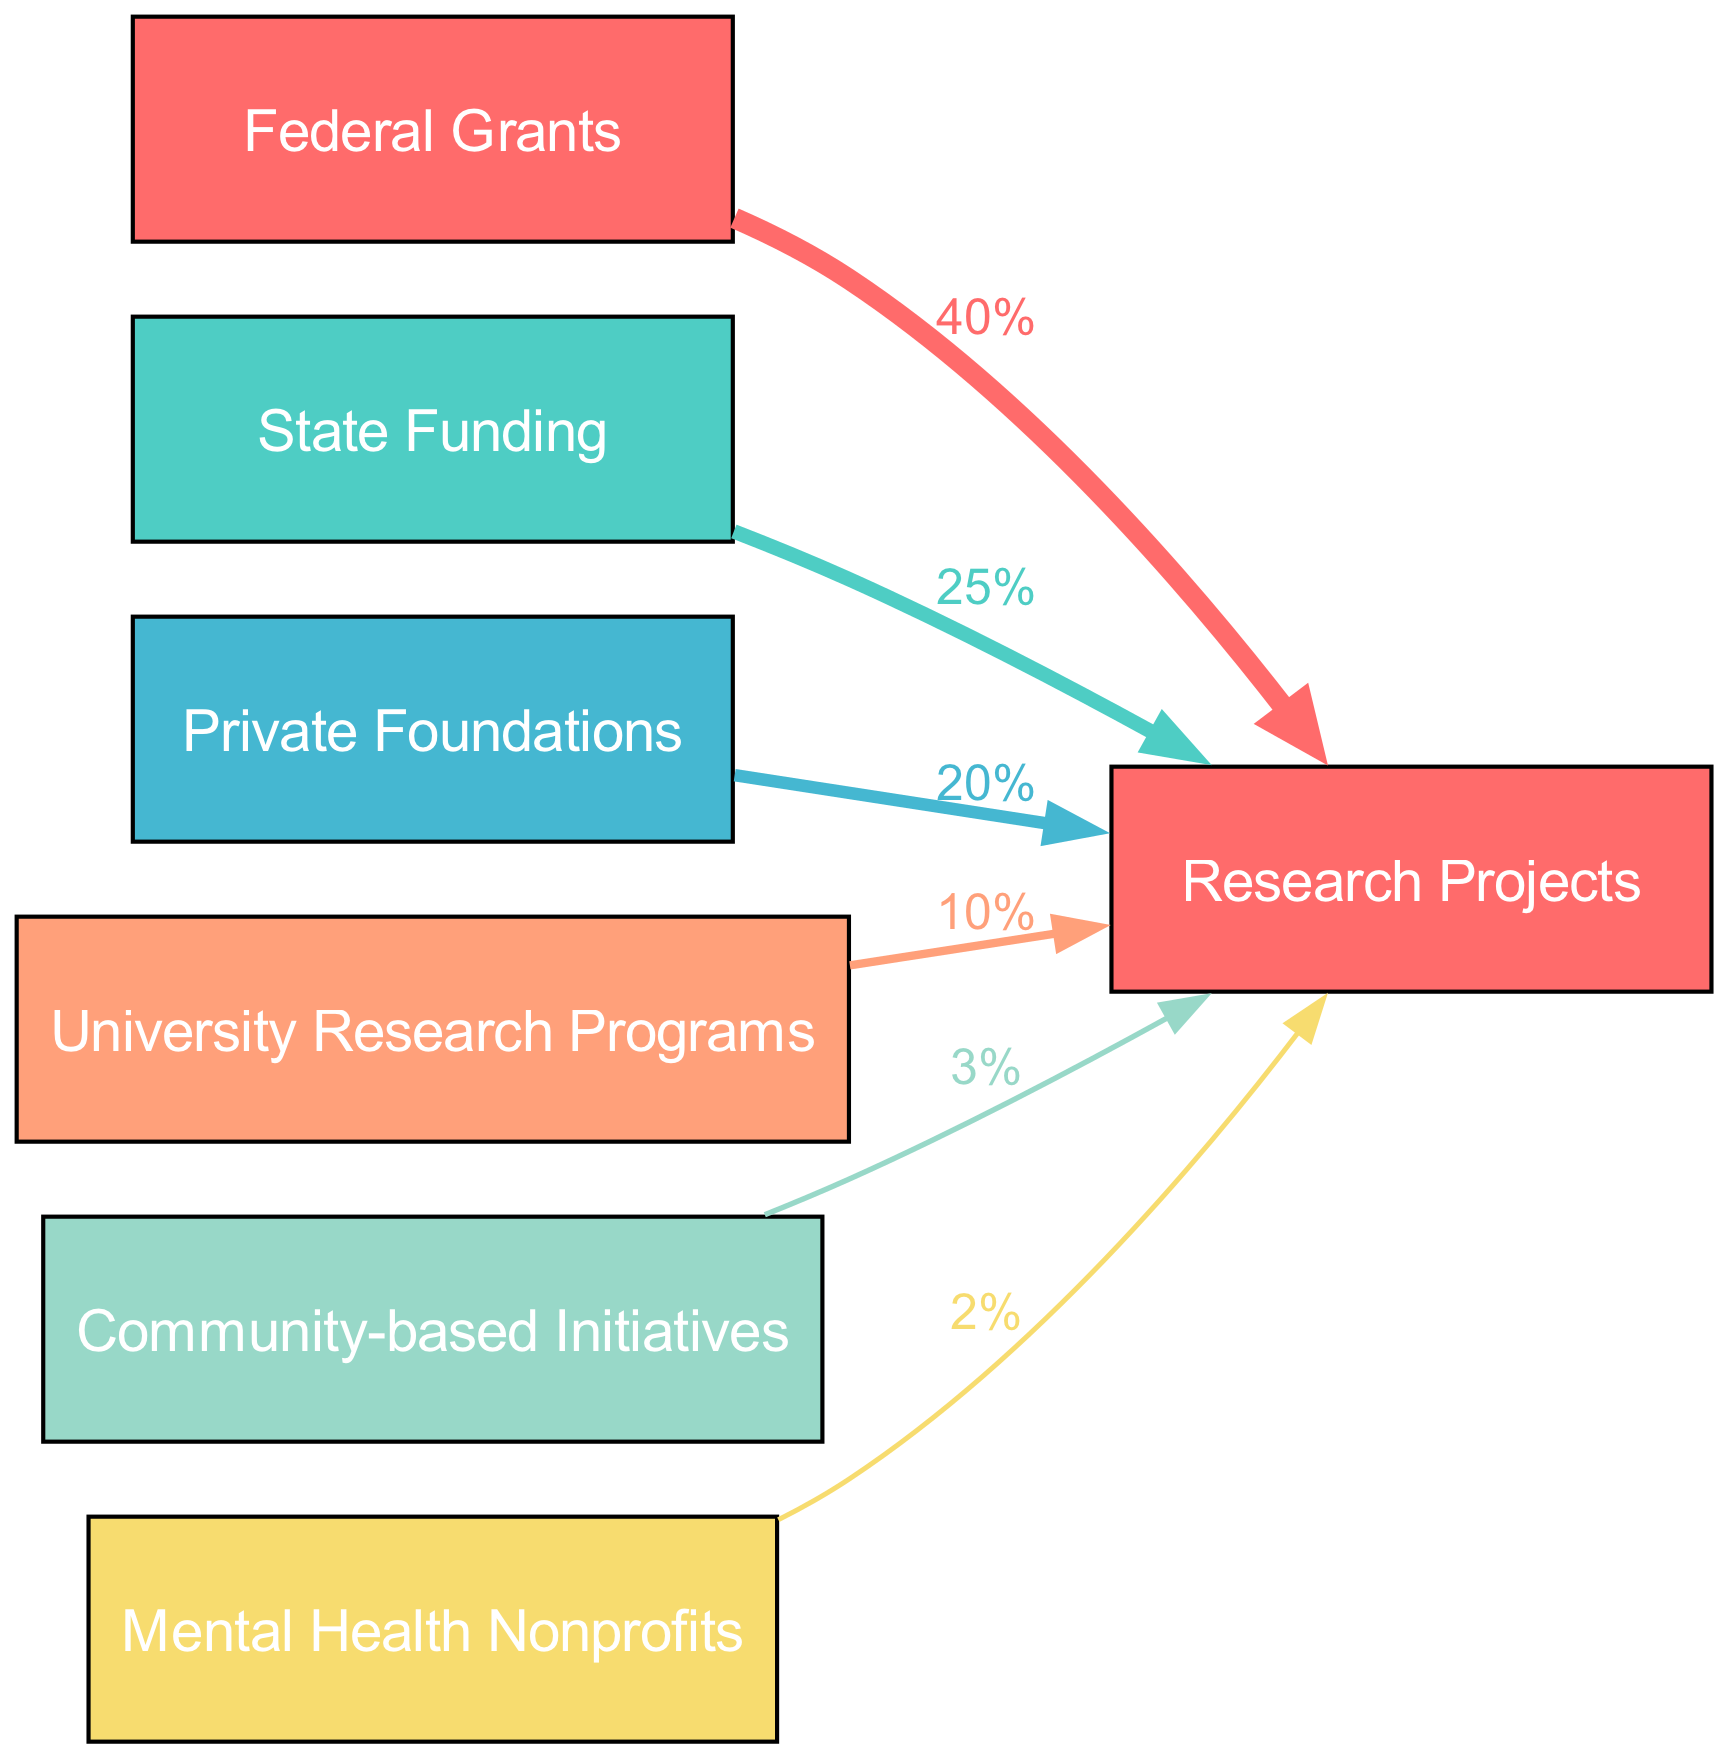What is the total funding from Federal Grants? The diagram shows a direct link from Federal Grants to Research Projects with a value labeled as 40%. This indicates that Federal Grants contribute a total of 40% of the funding for Research Projects.
Answer: 40% How many sources of funding are shown in the diagram? The diagram lists six sources: Federal Grants, State Funding, Private Foundations, University Research Programs, Community-based Initiatives, and Mental Health Nonprofits. Therefore, there are a total of six sources of funding displayed.
Answer: 6 Which funding source has the smallest allocation? By examining the links, the diagram reveals that Mental Health Nonprofits has a value of 2%, which is the smallest compared to other funding sources.
Answer: Mental Health Nonprofits What is the total value allocated to Research Projects? To find the total value allocated to Research Projects, we sum all the percentages for the links: 40% (Federal Grants) + 25% (State Funding) + 20% (Private Foundations) + 10% (University Research Programs) + 3% (Community-based Initiatives) + 2% (Mental Health Nonprofits) = 100%. Therefore, the total value allocated to Research Projects is 100%.
Answer: 100% Which funding source contributes more, State Funding or University Research Programs? The diagram provides values for each source: State Funding has a value of 25%, while University Research Programs has a value of 10%. Comparing these two values shows that State Funding contributes more to the Research Projects.
Answer: State Funding How does the funding from Private Foundations compare to that from Community-based Initiatives? The values indicate that Private Foundations allocate 20% and Community-based Initiatives allocate 3%. By comparing these values, it's clear that funding from Private Foundations is significantly higher than that from Community-based Initiatives.
Answer: Private Foundations What percentage of funding is provided by Community-based Initiatives? The diagram indicates that Community-based Initiatives has a value of 3% allocated to Research Projects. This specific label signifies the contribution given by this source.
Answer: 3% 